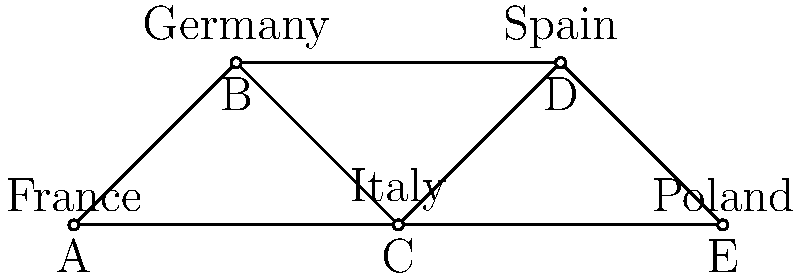In the graph above, vertices represent EU member states, and edges represent significant religious organization influence between states. What is the minimum number of states that need to be monitored to observe all religious organization influences in this network? To solve this problem, we need to find the minimum vertex cover of the graph. A vertex cover is a set of vertices such that every edge in the graph is incident to at least one vertex in the set. The steps to find the minimum vertex cover are:

1. Observe that the graph has 5 vertices (A, B, C, D, E) representing France, Germany, Italy, Spain, and Poland respectively.

2. Identify the edges:
   - A-B, B-C, C-D, D-E (forming a path)
   - A-C, C-E (additional connections)
   - B-D (an extra connection)

3. Look for vertices that cover multiple edges:
   - Vertex C (Italy) covers 4 edges: A-C, B-C, C-D, C-E
   - Vertex B (Germany) covers 3 edges: A-B, B-C, B-D

4. Selecting C (Italy) covers most of the edges, leaving only B-D uncovered.

5. To cover B-D, we need to select either B (Germany) or D (Spain). Choosing B is more efficient as it also covers A-B.

Therefore, the minimum vertex cover consists of vertices C (Italy) and B (Germany), which corresponds to monitoring these two states to observe all religious organization influences in the network.

The minimum number of states to be monitored is 2.
Answer: 2 